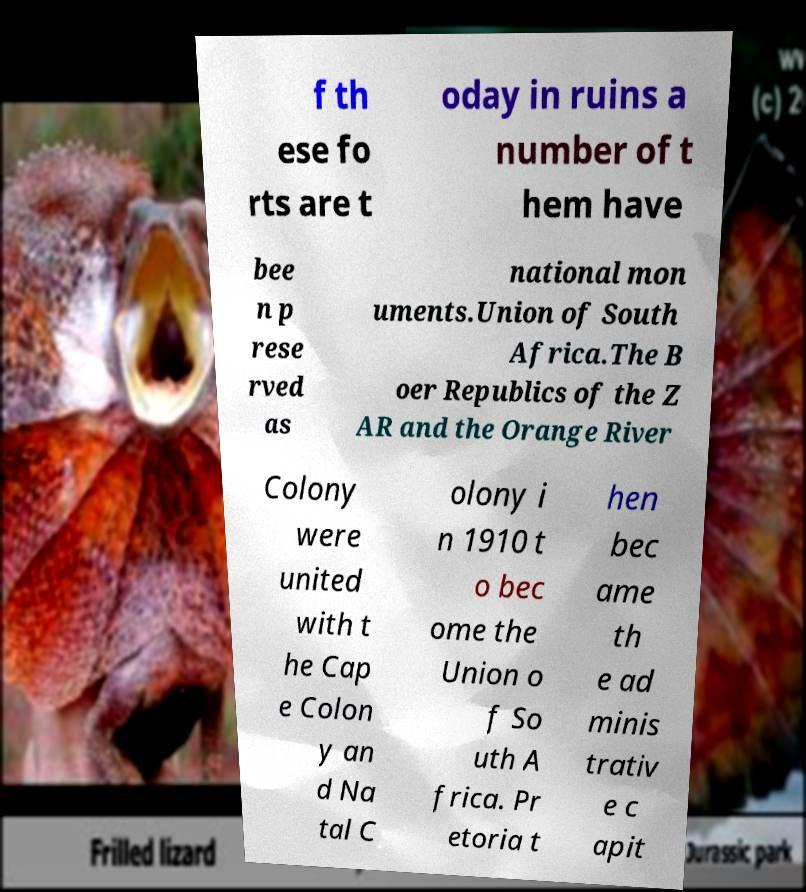Please read and relay the text visible in this image. What does it say? f th ese fo rts are t oday in ruins a number of t hem have bee n p rese rved as national mon uments.Union of South Africa.The B oer Republics of the Z AR and the Orange River Colony were united with t he Cap e Colon y an d Na tal C olony i n 1910 t o bec ome the Union o f So uth A frica. Pr etoria t hen bec ame th e ad minis trativ e c apit 